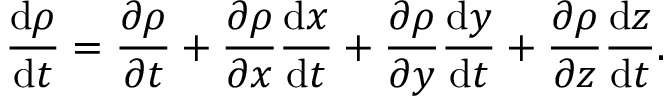<formula> <loc_0><loc_0><loc_500><loc_500>{ \frac { d \rho } { d t } } = { \frac { \partial \rho } { \partial t } } + { \frac { \partial \rho } { \partial x } } { \frac { d x } { d t } } + { \frac { \partial \rho } { \partial y } } { \frac { d y } { d t } } + { \frac { \partial \rho } { \partial z } } { \frac { d z } { d t } } .</formula> 